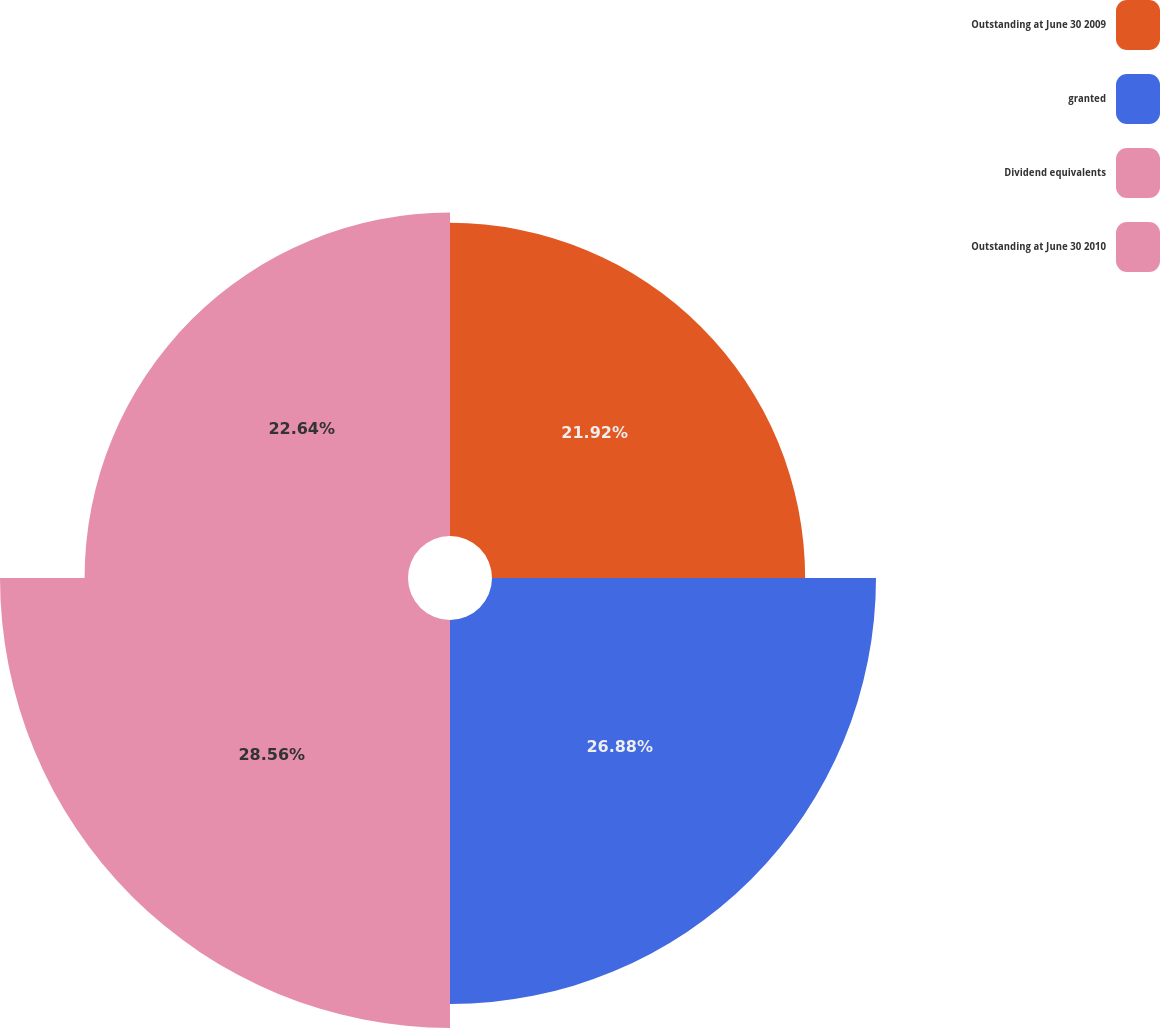Convert chart. <chart><loc_0><loc_0><loc_500><loc_500><pie_chart><fcel>Outstanding at June 30 2009<fcel>granted<fcel>Dividend equivalents<fcel>Outstanding at June 30 2010<nl><fcel>21.92%<fcel>26.88%<fcel>28.56%<fcel>22.64%<nl></chart> 